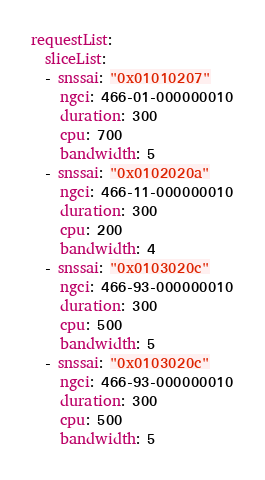<code> <loc_0><loc_0><loc_500><loc_500><_YAML_>requestList:
  sliceList:
  - snssai: "0x01010207"
    ngci: 466-01-000000010
    duration: 300
    cpu: 700
    bandwidth: 5
  - snssai: "0x0102020a"
    ngci: 466-11-000000010
    duration: 300
    cpu: 200
    bandwidth: 4
  - snssai: "0x0103020c"
    ngci: 466-93-000000010
    duration: 300
    cpu: 500
    bandwidth: 5
  - snssai: "0x0103020c"
    ngci: 466-93-000000010
    duration: 300
    cpu: 500
    bandwidth: 5
</code> 